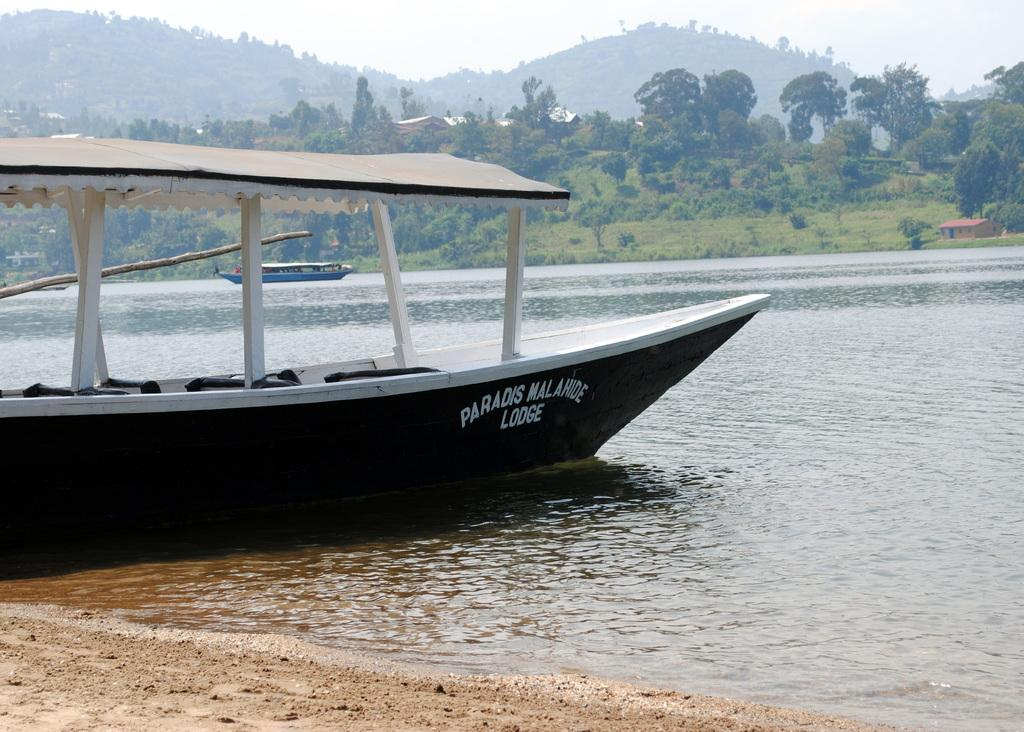What is in the water in the image? There are boats in the water. What type of vegetation can be seen in the background? There are plants and trees in the background. What type of structures are visible in the background? There are houses in the background. What natural feature can be seen in the background? There is a mountain in the background. What part of the sky is visible in the image? The sky is visible in the background. What type of fruit is hanging from the trees in the image? There is no fruit visible in the image; only trees, houses, and a mountain are present in the background. What level of friction can be observed between the boats and the water in the image? The image does not provide information about the level of friction between the boats and the water. 